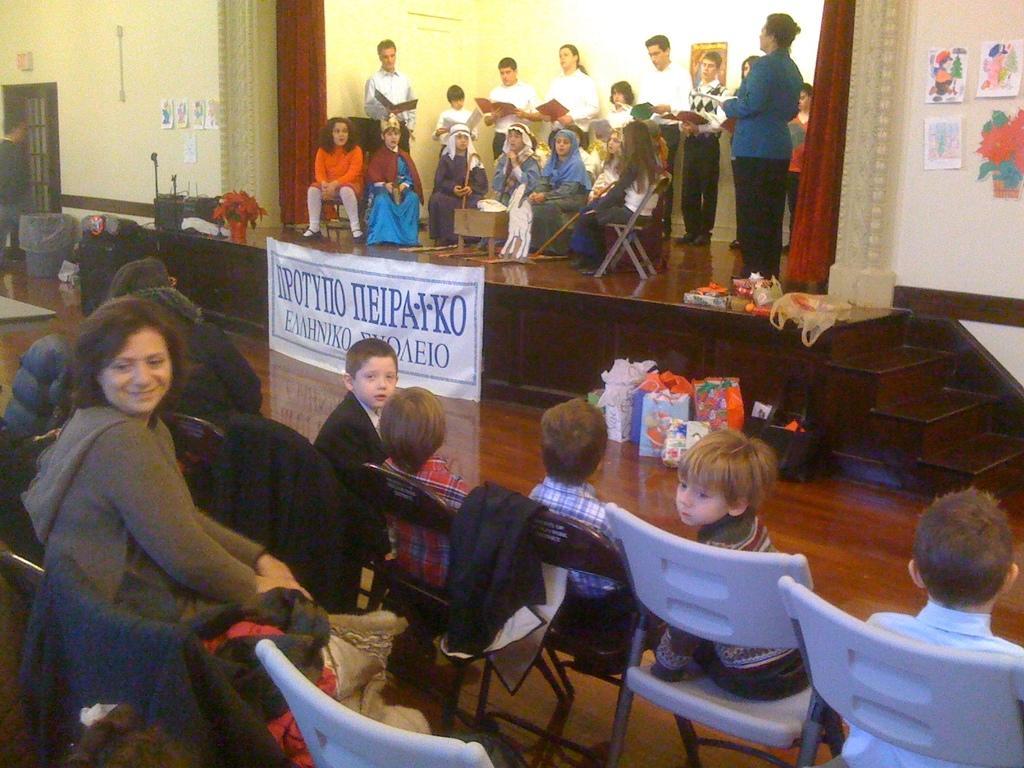How would you summarize this image in a sentence or two? In this picture we can see group of people some are on stage and some are reading books holding in their hands and some are sitting on chair and in front of stage we can see children's sitting on chairs here woman smiling and in background we can see wall, door, frames, flower pot, bin, steps, bags, banner, curtain. 